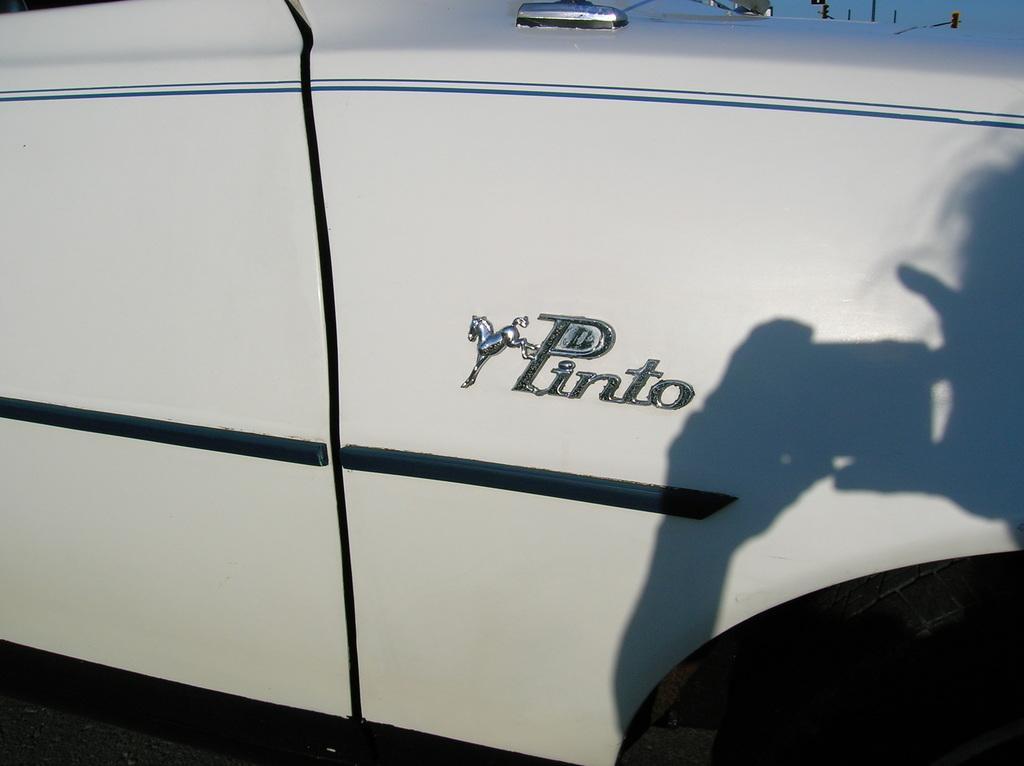Describe this image in one or two sentences. In the center of the image there is a car. 